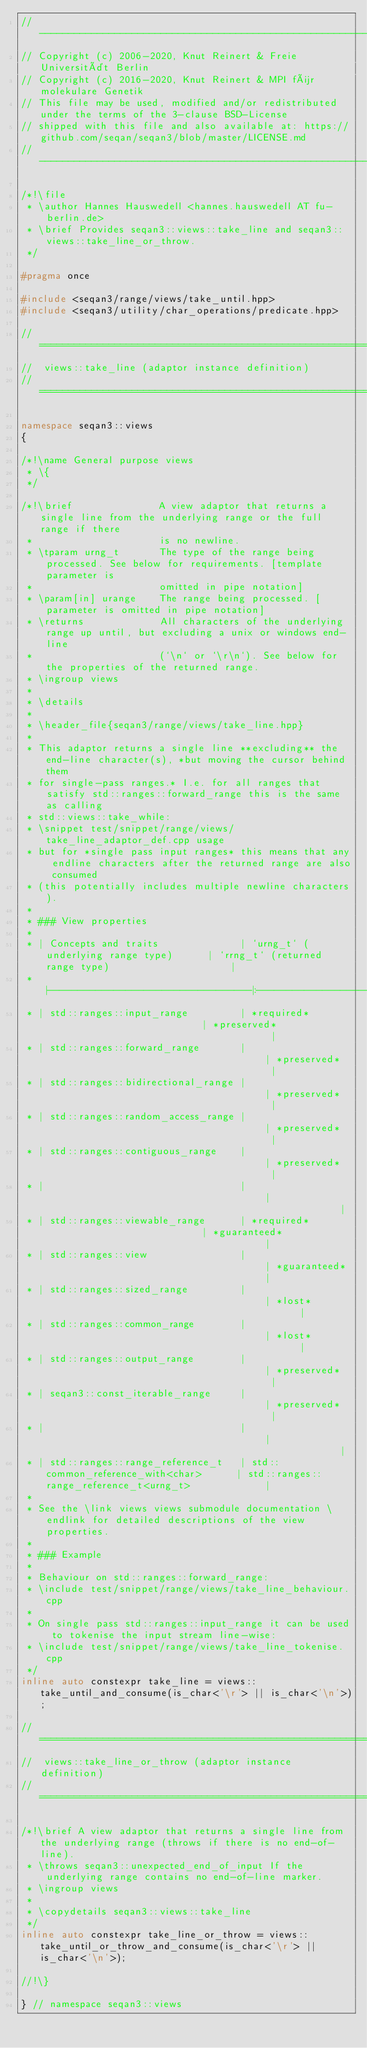Convert code to text. <code><loc_0><loc_0><loc_500><loc_500><_C++_>// -----------------------------------------------------------------------------------------------------
// Copyright (c) 2006-2020, Knut Reinert & Freie Universität Berlin
// Copyright (c) 2016-2020, Knut Reinert & MPI für molekulare Genetik
// This file may be used, modified and/or redistributed under the terms of the 3-clause BSD-License
// shipped with this file and also available at: https://github.com/seqan/seqan3/blob/master/LICENSE.md
// -----------------------------------------------------------------------------------------------------

/*!\file
 * \author Hannes Hauswedell <hannes.hauswedell AT fu-berlin.de>
 * \brief Provides seqan3::views::take_line and seqan3::views::take_line_or_throw.
 */

#pragma once

#include <seqan3/range/views/take_until.hpp>
#include <seqan3/utility/char_operations/predicate.hpp>

// ============================================================================
//  views::take_line (adaptor instance definition)
// ============================================================================

namespace seqan3::views
{

/*!\name General purpose views
 * \{
 */

/*!\brief               A view adaptor that returns a single line from the underlying range or the full range if there
 *                      is no newline.
 * \tparam urng_t       The type of the range being processed. See below for requirements. [template parameter is
 *                      omitted in pipe notation]
 * \param[in] urange    The range being processed. [parameter is omitted in pipe notation]
 * \returns             All characters of the underlying range up until, but excluding a unix or windows end-line
 *                      (`\n` or `\r\n`). See below for the properties of the returned range.
 * \ingroup views
 *
 * \details
 *
 * \header_file{seqan3/range/views/take_line.hpp}
 *
 * This adaptor returns a single line **excluding** the end-line character(s), *but moving the cursor behind them
 * for single-pass ranges.* I.e. for all ranges that satisfy std::ranges::forward_range this is the same as calling
 * std::views::take_while:
 * \snippet test/snippet/range/views/take_line_adaptor_def.cpp usage
 * but for *single pass input ranges* this means that any endline characters after the returned range are also consumed
 * (this potentially includes multiple newline characters).
 *
 * ### View properties
 *
 * | Concepts and traits              | `urng_t` (underlying range type)      | `rrng_t` (returned range type)                     |
 * |----------------------------------|:-------------------------------------:|:--------------------------------------------------:|
 * | std::ranges::input_range         | *required*                            | *preserved*                                        |
 * | std::ranges::forward_range       |                                       | *preserved*                                        |
 * | std::ranges::bidirectional_range |                                       | *preserved*                                        |
 * | std::ranges::random_access_range |                                       | *preserved*                                        |
 * | std::ranges::contiguous_range    |                                       | *preserved*                                        |
 * |                                  |                                       |                                                    |
 * | std::ranges::viewable_range      | *required*                            | *guaranteed*                                       |
 * | std::ranges::view                |                                       | *guaranteed*                                       |
 * | std::ranges::sized_range         |                                       | *lost*                                             |
 * | std::ranges::common_range        |                                       | *lost*                                             |
 * | std::ranges::output_range        |                                       | *preserved*                                        |
 * | seqan3::const_iterable_range     |                                       | *preserved*                                        |
 * |                                  |                                       |                                                    |
 * | std::ranges::range_reference_t   | std::common_reference_with<char>      | std::ranges::range_reference_t<urng_t>             |
 *
 * See the \link views views submodule documentation \endlink for detailed descriptions of the view properties.
 *
 * ### Example
 *
 * Behaviour on std::ranges::forward_range:
 * \include test/snippet/range/views/take_line_behaviour.cpp
 *
 * On single pass std::ranges::input_range it can be used to tokenise the input stream line-wise:
 * \include test/snippet/range/views/take_line_tokenise.cpp
 */
inline auto constexpr take_line = views::take_until_and_consume(is_char<'\r'> || is_char<'\n'>);

// ============================================================================
//  views::take_line_or_throw (adaptor instance definition)
// ============================================================================

/*!\brief A view adaptor that returns a single line from the underlying range (throws if there is no end-of-line).
 * \throws seqan3::unexpected_end_of_input If the underlying range contains no end-of-line marker.
 * \ingroup views
 *
 * \copydetails seqan3::views::take_line
 */
inline auto constexpr take_line_or_throw = views::take_until_or_throw_and_consume(is_char<'\r'> || is_char<'\n'>);

//!\}

} // namespace seqan3::views
</code> 